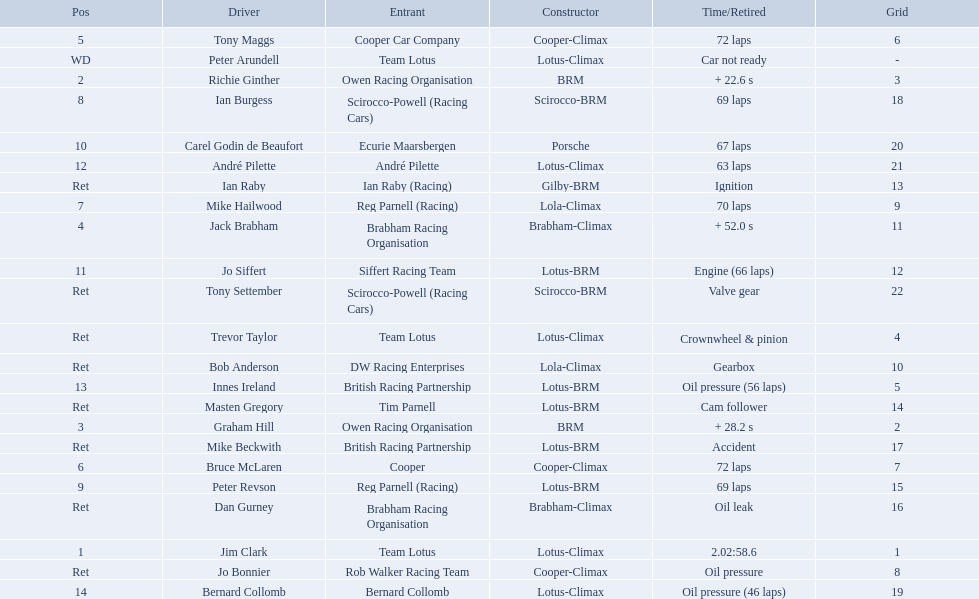Who all drive cars that were constructed bur climax? Jim Clark, Jack Brabham, Tony Maggs, Bruce McLaren, Mike Hailwood, André Pilette, Bernard Collomb, Dan Gurney, Trevor Taylor, Jo Bonnier, Bob Anderson, Peter Arundell. Which driver's climax constructed cars started in the top 10 on the grid? Jim Clark, Tony Maggs, Bruce McLaren, Mike Hailwood, Jo Bonnier, Bob Anderson. Of the top 10 starting climax constructed drivers, which ones did not finish the race? Jo Bonnier, Bob Anderson. What was the failure that was engine related that took out the driver of the climax constructed car that did not finish even though it started in the top 10? Oil pressure. 